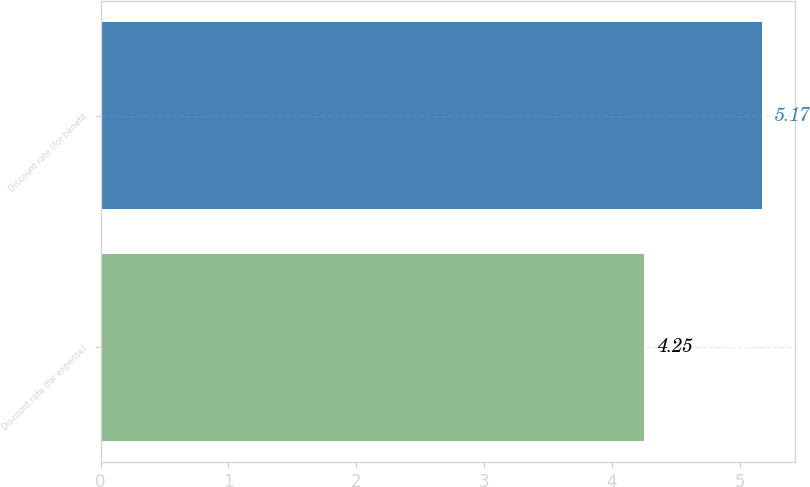<chart> <loc_0><loc_0><loc_500><loc_500><bar_chart><fcel>Discount rate (for expense)<fcel>Discount rate (for benefit<nl><fcel>4.25<fcel>5.17<nl></chart> 